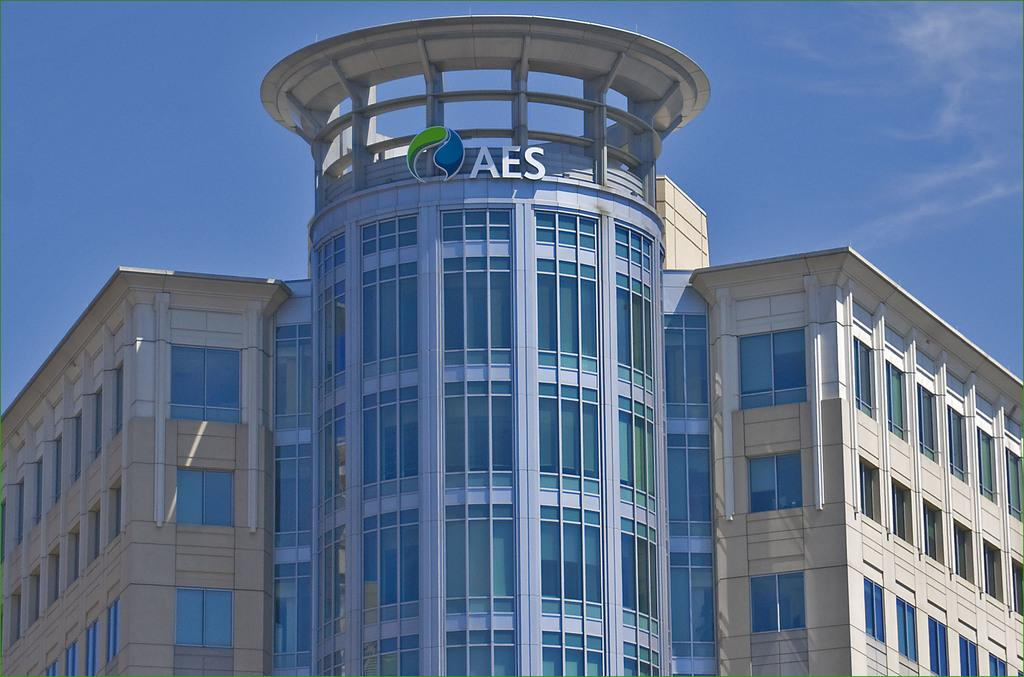What type of structure is visible in the image? There is a building in the image. What color is the sky in the background of the image? The sky is blue in the background of the image. How many gloves are being used by the giants in the image? There are no giants or gloves present in the image. 